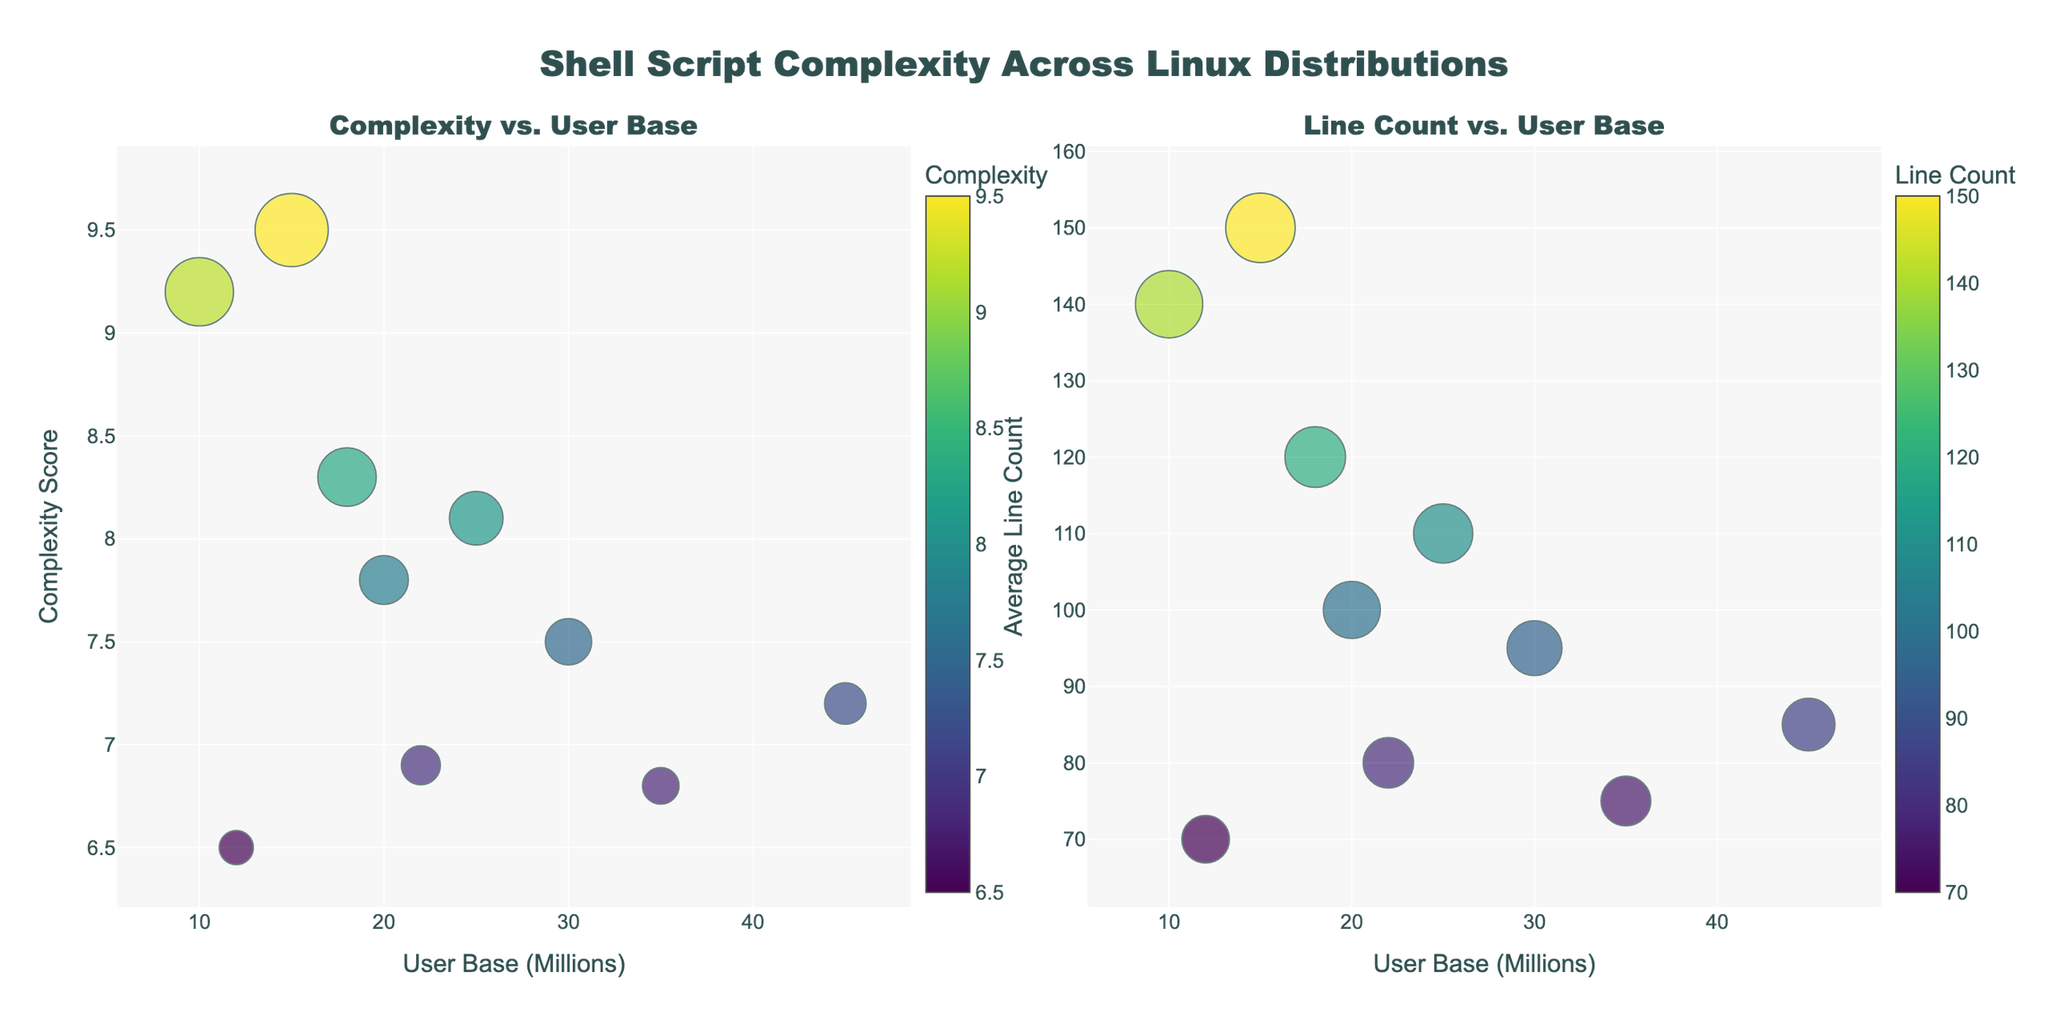what's the main title of the figure? The main title is located at the top center of the figure and summarizes the overall content.
Answer: Playground Equipment Growth Over the Years How many data points are there for each type of playground equipment? Each subplot representing different types of playground equipment has data points corresponding to the years from 2013 to 2022, so each subplot has 10 data points.
Answer: 10 What color is used for the line representing "Slides"? The color used for each line can be identified by looking at its visual appearance. For 'Slides,' it is a distinct shade indicated by the color palette used.
Answer: Light Blue In which year did 'Swings' surpass 'Slides' in count? First, identify the years on the x-axis, then check the corresponding y-axis values for 'Swings' and 'Slides' to find where 'Swings' count becomes higher than 'Slides'. In 2016, 'Swings' (22) surpassed 'Slides' (18).
Answer: 2016 How many 'Sandboxes' were there in 2020? Find the 'Sandboxes' subplot, then locate the year 2020 on the x-axis and check its corresponding value on the y-axis.
Answer: 15 Which playground equipment has decreased in count over the years? Identify the subplot where the line representing the count steadily decreases from 2013 to 2022. The line for 'Seesaws' shows a steady decrease.
Answer: Seesaws What is the difference in the count of 'Swings' between 2013 and 2022? Find the 'Swings' subplot and note the y-axis values for the years 2013 and 2022, then calculate the difference: 38 (2022) - 15 (2013).
Answer: 23 How many types of playground equipment increased in count every year from 2013 to 2022? Check each subplot for consistent yearly increases. 'Swings,' 'Slides,' 'Jungle Gyms,' and 'Sandboxes' all show an increase every year.
Answer: 4 Which year had the highest increase in 'Jungle Gyms' count compared to the previous year? Identify the year-on-year differences for 'Jungle Gyms' and find the maximum increase. 2018 had the highest increase from 15 (2017) to 18 (2018).
Answer: 2018 By how much did the count of 'Slides' increase from 2014 to 2018? Find the y-axis values for 'Slides' in the years 2014 and 2018 and calculate the increase: 22 (2018) - 14 (2014).
Answer: 8 